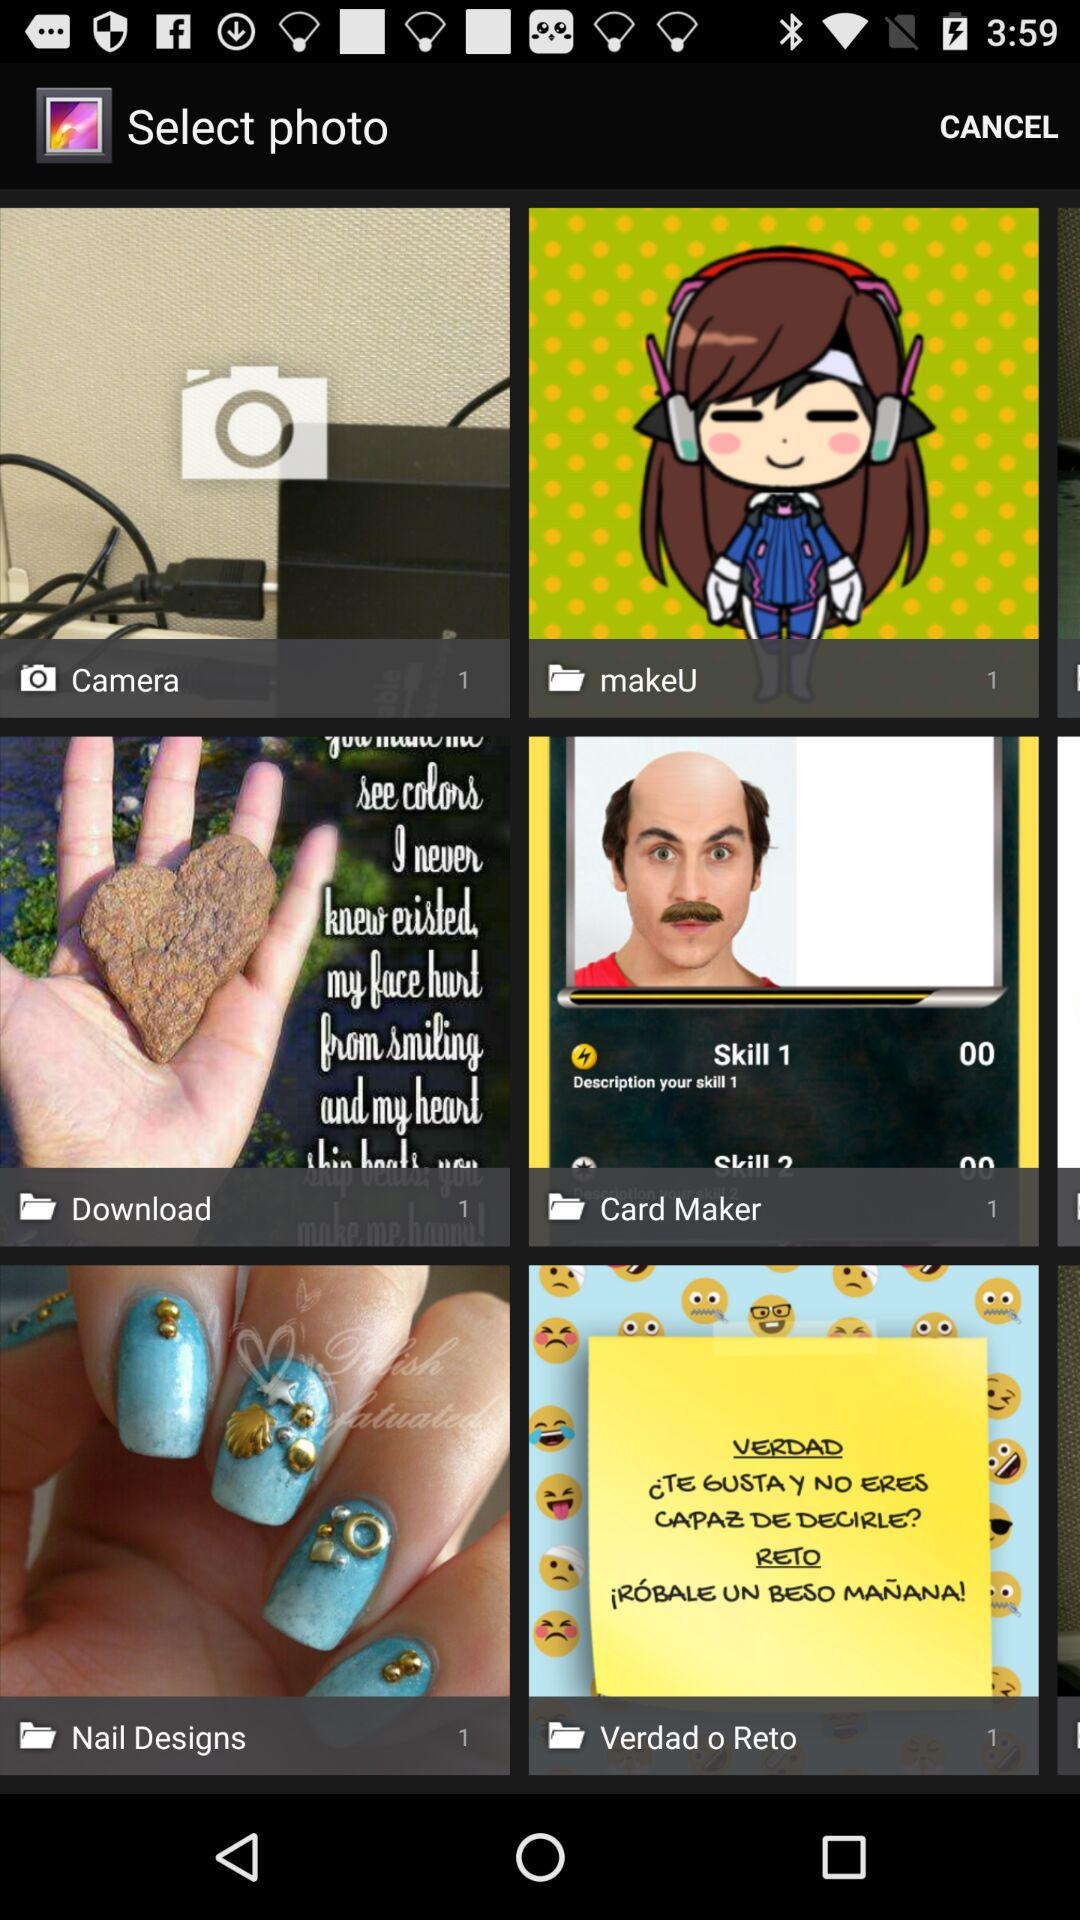How many photographs are there in "Download"? There is 1 photograph in "Download". 